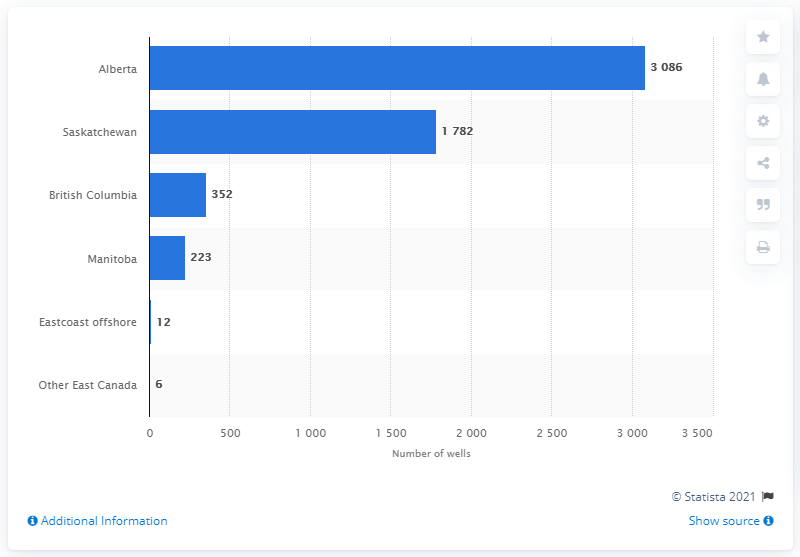Give some essential details in this illustration. In 2019, a total of 352 wells were drilled in British Columbia. In 2019, Alberta was the province with the highest number of oil and gas wells drilled. 